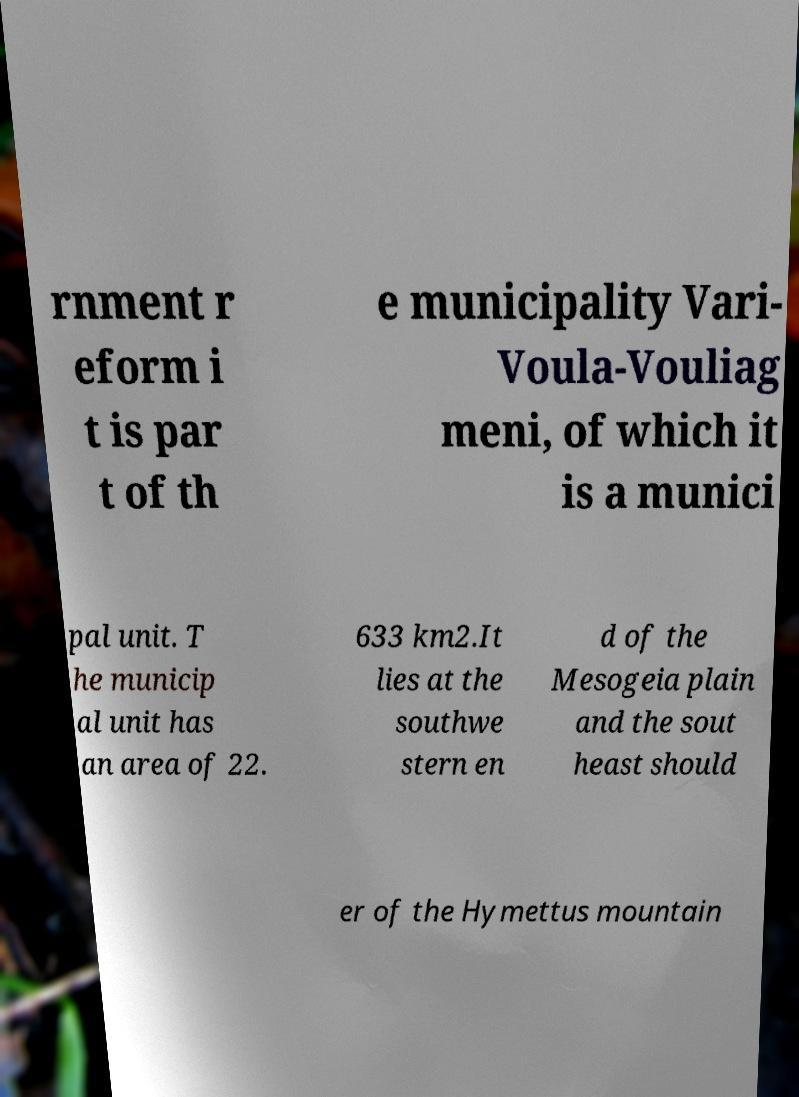There's text embedded in this image that I need extracted. Can you transcribe it verbatim? rnment r eform i t is par t of th e municipality Vari- Voula-Vouliag meni, of which it is a munici pal unit. T he municip al unit has an area of 22. 633 km2.It lies at the southwe stern en d of the Mesogeia plain and the sout heast should er of the Hymettus mountain 